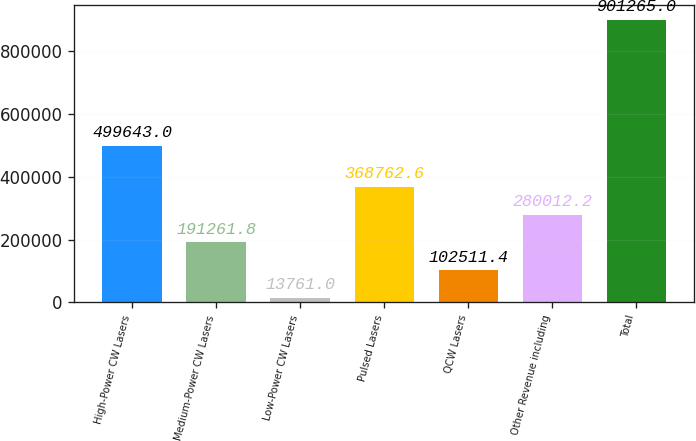Convert chart to OTSL. <chart><loc_0><loc_0><loc_500><loc_500><bar_chart><fcel>High-Power CW Lasers<fcel>Medium-Power CW Lasers<fcel>Low-Power CW Lasers<fcel>Pulsed Lasers<fcel>QCW Lasers<fcel>Other Revenue including<fcel>Total<nl><fcel>499643<fcel>191262<fcel>13761<fcel>368763<fcel>102511<fcel>280012<fcel>901265<nl></chart> 